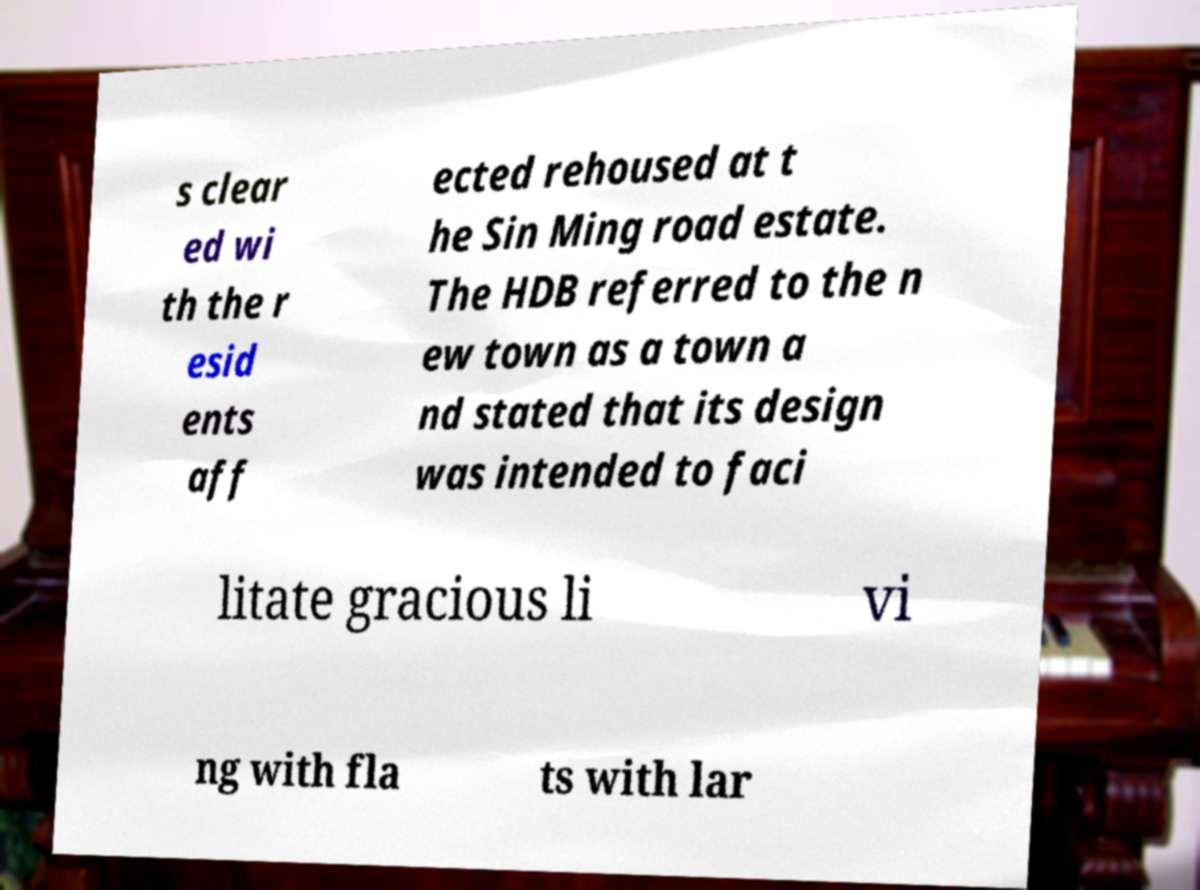Could you extract and type out the text from this image? s clear ed wi th the r esid ents aff ected rehoused at t he Sin Ming road estate. The HDB referred to the n ew town as a town a nd stated that its design was intended to faci litate gracious li vi ng with fla ts with lar 